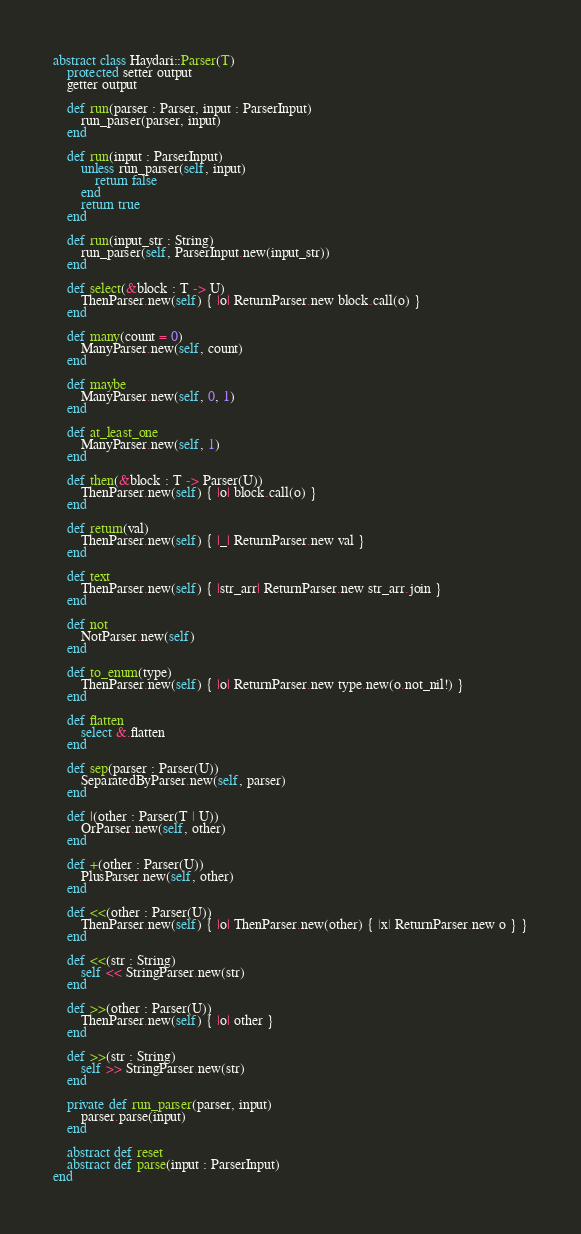<code> <loc_0><loc_0><loc_500><loc_500><_Crystal_>abstract class Haydari::Parser(T)
    protected setter output
    getter output

    def run(parser : Parser, input : ParserInput)
        run_parser(parser, input)
    end

    def run(input : ParserInput)
        unless run_parser(self, input)
            return false
        end
        return true
    end

    def run(input_str : String)
        run_parser(self, ParserInput.new(input_str))
    end

    def select(&block : T -> U)
        ThenParser.new(self) { |o| ReturnParser.new block.call(o) }
    end

    def many(count = 0)
        ManyParser.new(self, count)
    end

    def maybe
        ManyParser.new(self, 0, 1)
    end

    def at_least_one
        ManyParser.new(self, 1)
    end

    def then(&block : T -> Parser(U))
        ThenParser.new(self) { |o| block.call(o) }
    end

    def return(val)
        ThenParser.new(self) { |_| ReturnParser.new val }
    end

    def text
        ThenParser.new(self) { |str_arr| ReturnParser.new str_arr.join }
    end

    def not
        NotParser.new(self)
    end

    def to_enum(type)
        ThenParser.new(self) { |o| ReturnParser.new type.new(o.not_nil!) }
    end

    def flatten
        select &.flatten
    end

    def sep(parser : Parser(U))
        SeparatedByParser.new(self, parser)
    end

    def |(other : Parser(T | U))
        OrParser.new(self, other)
    end

    def +(other : Parser(U))
        PlusParser.new(self, other)
    end

    def <<(other : Parser(U))
        ThenParser.new(self) { |o| ThenParser.new(other) { |x| ReturnParser.new o } }
    end

    def <<(str : String)
        self << StringParser.new(str)
    end

    def >>(other : Parser(U))
        ThenParser.new(self) { |o| other }
    end

    def >>(str : String)
        self >> StringParser.new(str)
    end

    private def run_parser(parser, input)
        parser.parse(input)
    end

    abstract def reset
    abstract def parse(input : ParserInput)
end


</code> 